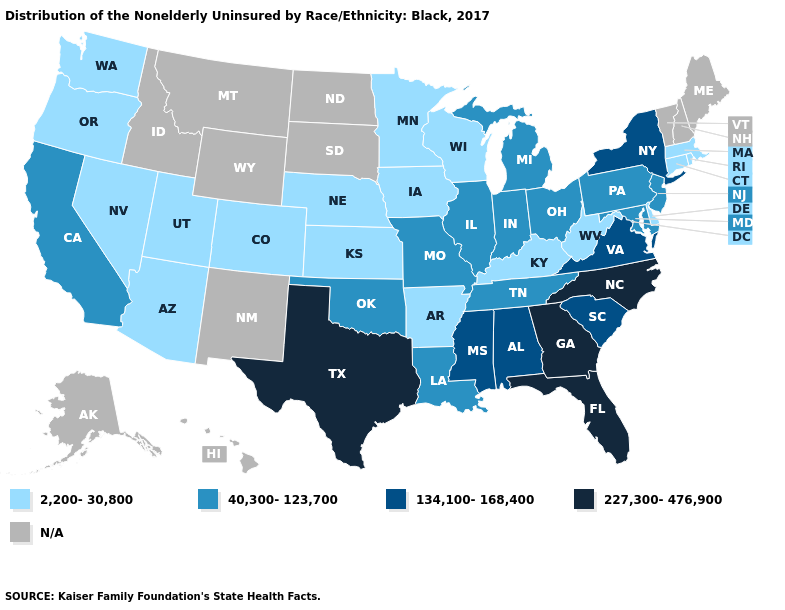Name the states that have a value in the range 2,200-30,800?
Short answer required. Arizona, Arkansas, Colorado, Connecticut, Delaware, Iowa, Kansas, Kentucky, Massachusetts, Minnesota, Nebraska, Nevada, Oregon, Rhode Island, Utah, Washington, West Virginia, Wisconsin. Does Georgia have the highest value in the USA?
Answer briefly. Yes. What is the value of Ohio?
Concise answer only. 40,300-123,700. Name the states that have a value in the range 40,300-123,700?
Keep it brief. California, Illinois, Indiana, Louisiana, Maryland, Michigan, Missouri, New Jersey, Ohio, Oklahoma, Pennsylvania, Tennessee. Which states have the lowest value in the USA?
Short answer required. Arizona, Arkansas, Colorado, Connecticut, Delaware, Iowa, Kansas, Kentucky, Massachusetts, Minnesota, Nebraska, Nevada, Oregon, Rhode Island, Utah, Washington, West Virginia, Wisconsin. Does South Carolina have the highest value in the USA?
Short answer required. No. What is the lowest value in the Northeast?
Concise answer only. 2,200-30,800. Is the legend a continuous bar?
Concise answer only. No. Among the states that border Nevada , which have the lowest value?
Answer briefly. Arizona, Oregon, Utah. Which states hav the highest value in the South?
Be succinct. Florida, Georgia, North Carolina, Texas. What is the lowest value in states that border Connecticut?
Keep it brief. 2,200-30,800. Does the map have missing data?
Keep it brief. Yes. What is the value of Texas?
Quick response, please. 227,300-476,900. Name the states that have a value in the range 2,200-30,800?
Concise answer only. Arizona, Arkansas, Colorado, Connecticut, Delaware, Iowa, Kansas, Kentucky, Massachusetts, Minnesota, Nebraska, Nevada, Oregon, Rhode Island, Utah, Washington, West Virginia, Wisconsin. 